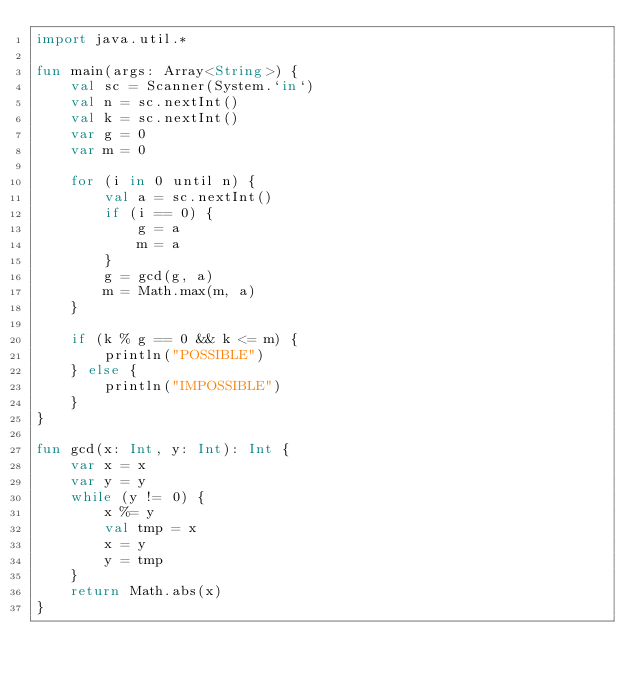<code> <loc_0><loc_0><loc_500><loc_500><_Kotlin_>import java.util.*

fun main(args: Array<String>) {
    val sc = Scanner(System.`in`)
    val n = sc.nextInt()
    val k = sc.nextInt()
    var g = 0
    var m = 0

    for (i in 0 until n) {
        val a = sc.nextInt()
        if (i == 0) {
            g = a
            m = a
        }
        g = gcd(g, a)
        m = Math.max(m, a)
    }

    if (k % g == 0 && k <= m) {
        println("POSSIBLE")
    } else {
        println("IMPOSSIBLE")
    }
}

fun gcd(x: Int, y: Int): Int {
    var x = x
    var y = y
    while (y != 0) {
        x %= y
        val tmp = x
        x = y
        y = tmp
    }
    return Math.abs(x)
}
</code> 